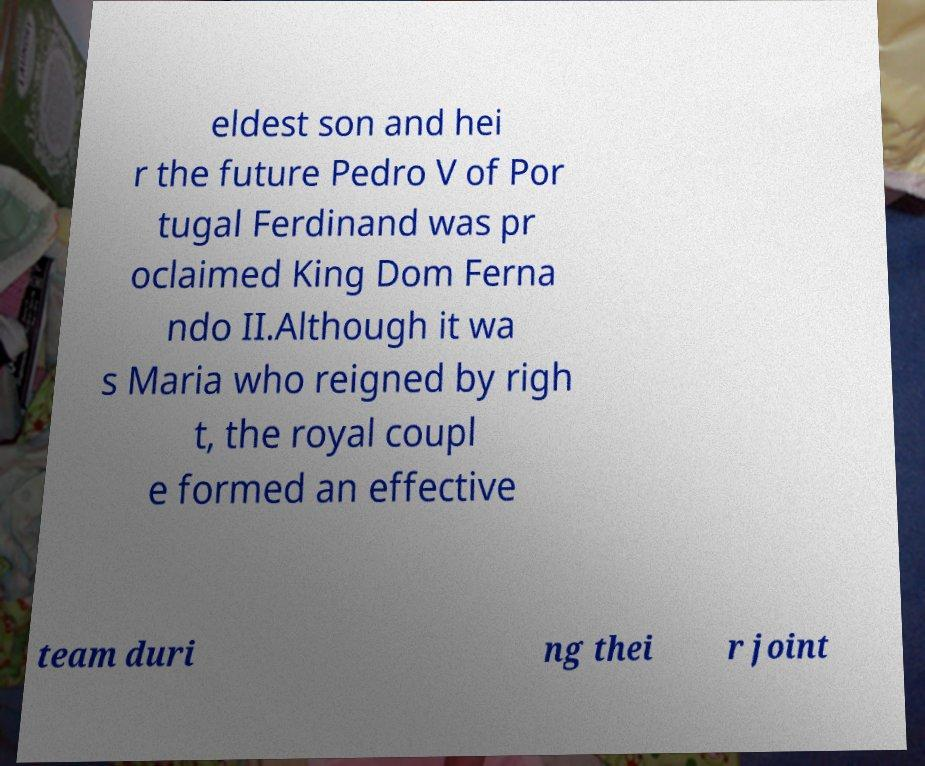Could you extract and type out the text from this image? eldest son and hei r the future Pedro V of Por tugal Ferdinand was pr oclaimed King Dom Ferna ndo II.Although it wa s Maria who reigned by righ t, the royal coupl e formed an effective team duri ng thei r joint 